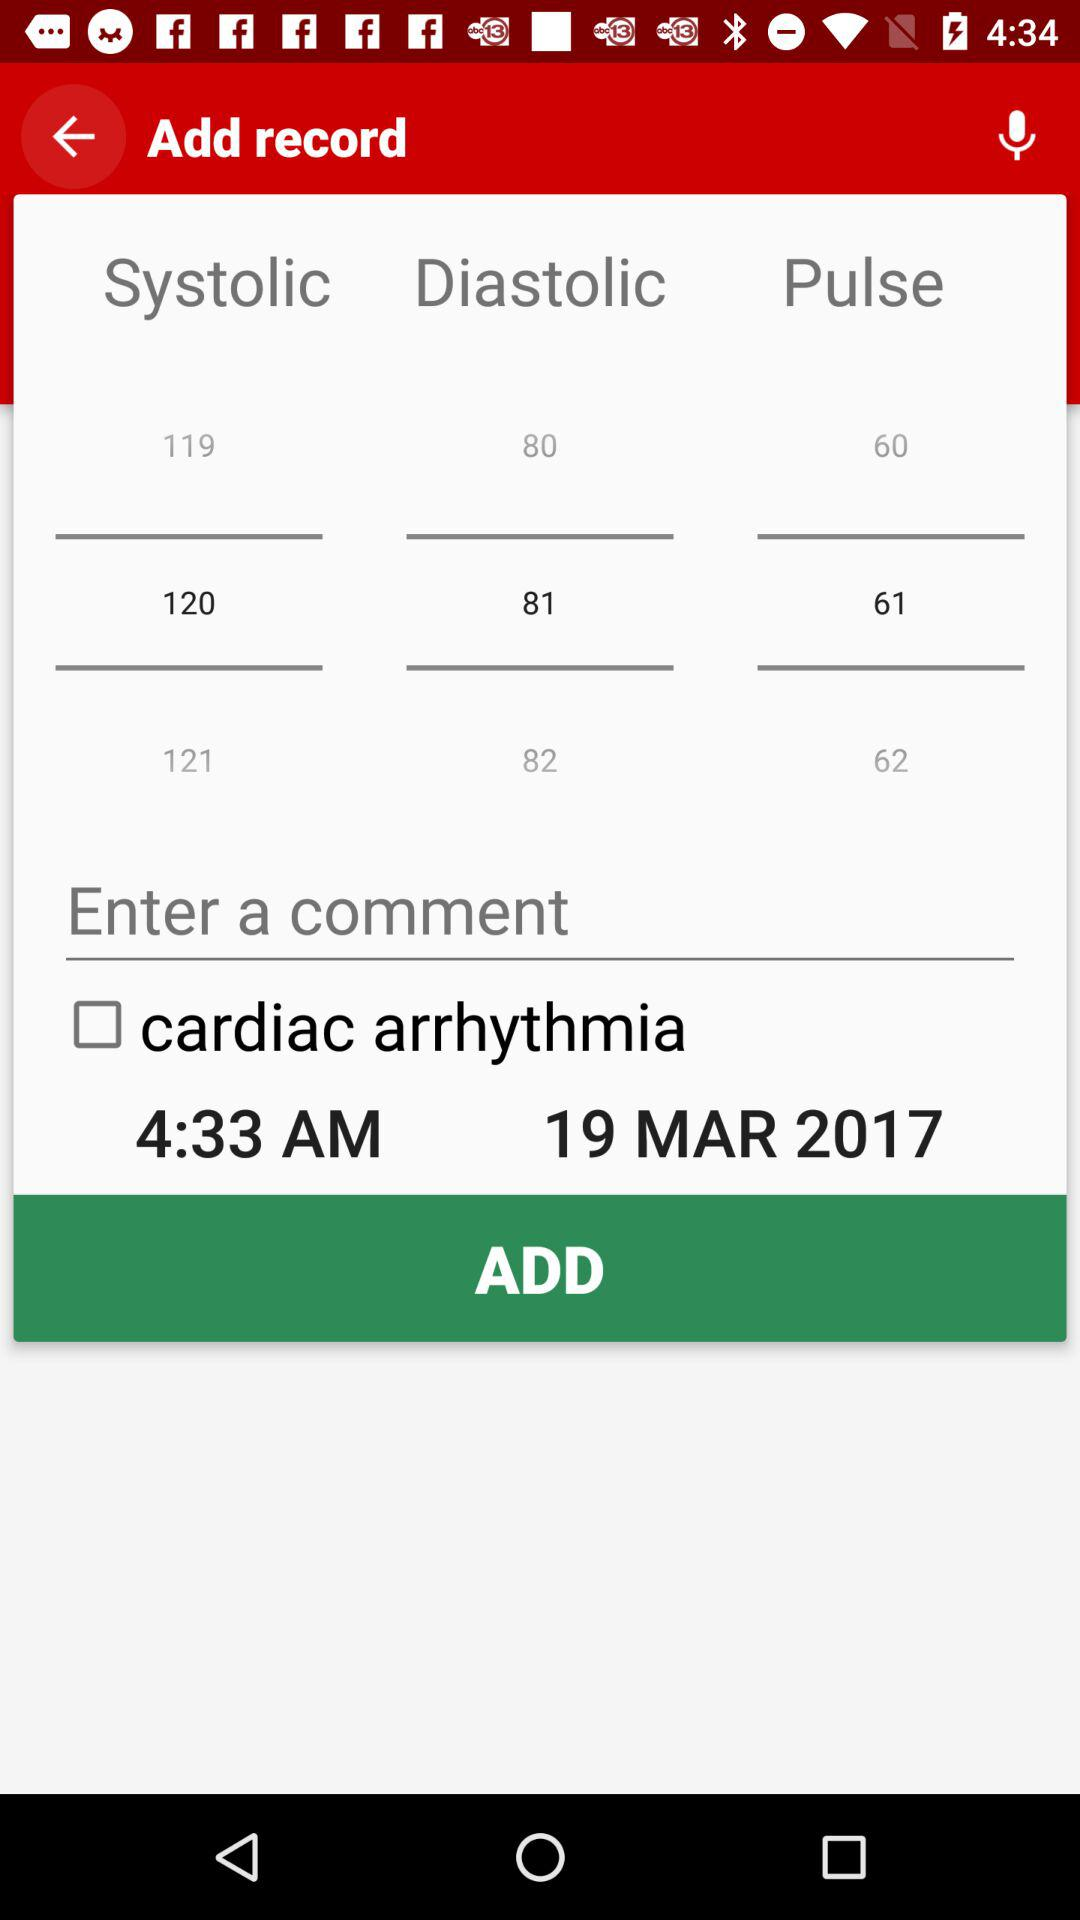On which date is this record going to be added? The date is March 19, 2017. 